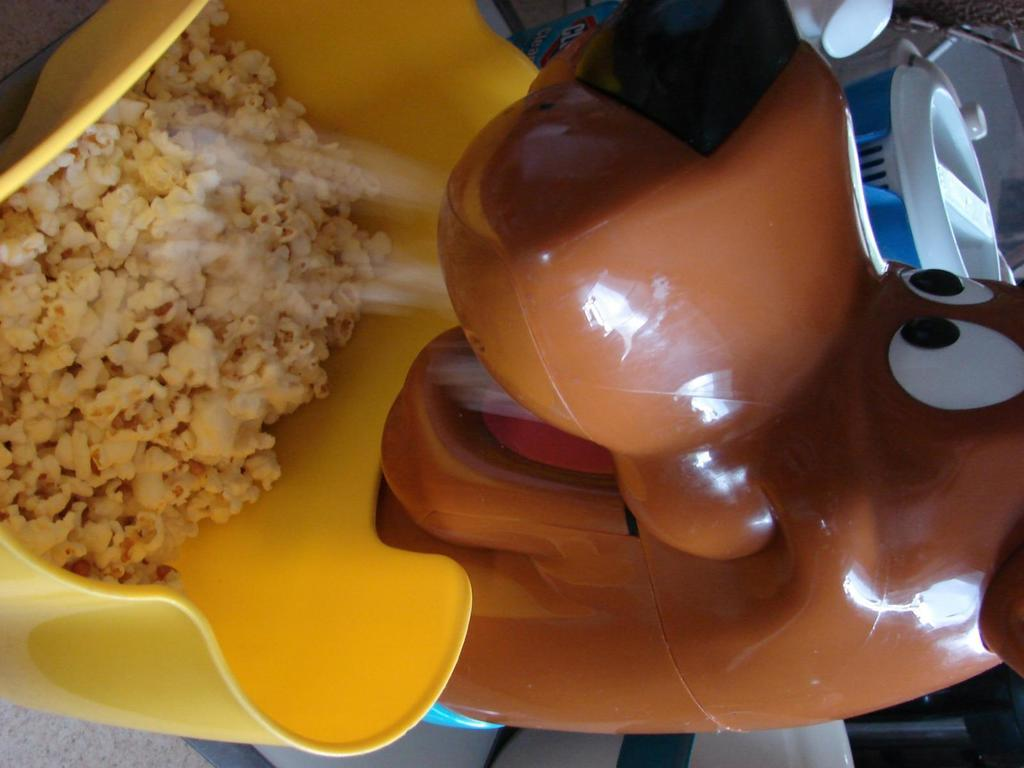What is the main object in the image? There is a popcorn machine in the image. Can you describe any other objects or features in the image? There are objects at the top right side of the image. What type of cannon is used to make the popcorn in the image? There is no cannon present in the image; it is a popcorn machine that makes the popcorn. What material is the plastic used for in the image? There is no mention of plastic in the image, as it only features a popcorn machine and objects at the top right side. 